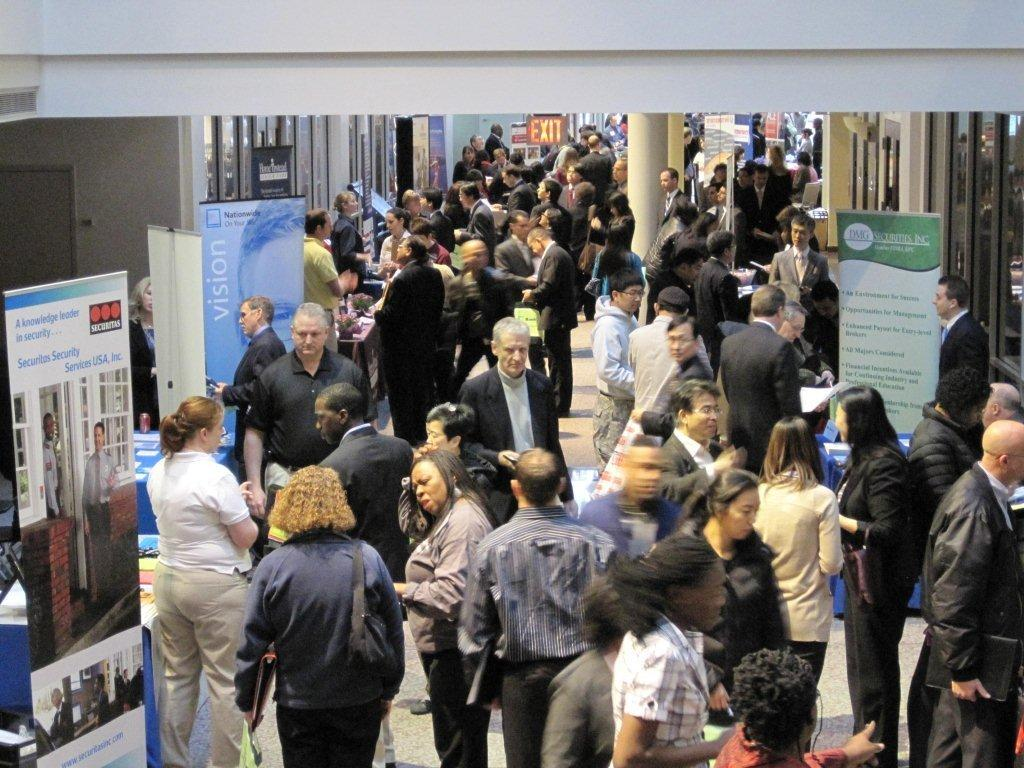What type of surface is visible in the image? There is ground visible in the image. What are the people in the image doing? There are people standing on the ground in the image. What decorative elements can be seen in the image? There are banners and an exit board in the image. What architectural features are present in the image? There are pillars and buildings visible in the image. How many people are sleeping in the image? There is no indication of anyone sleeping in the image. What type of crack is visible on the ground in the image? There is no crack visible on the ground in the image. 